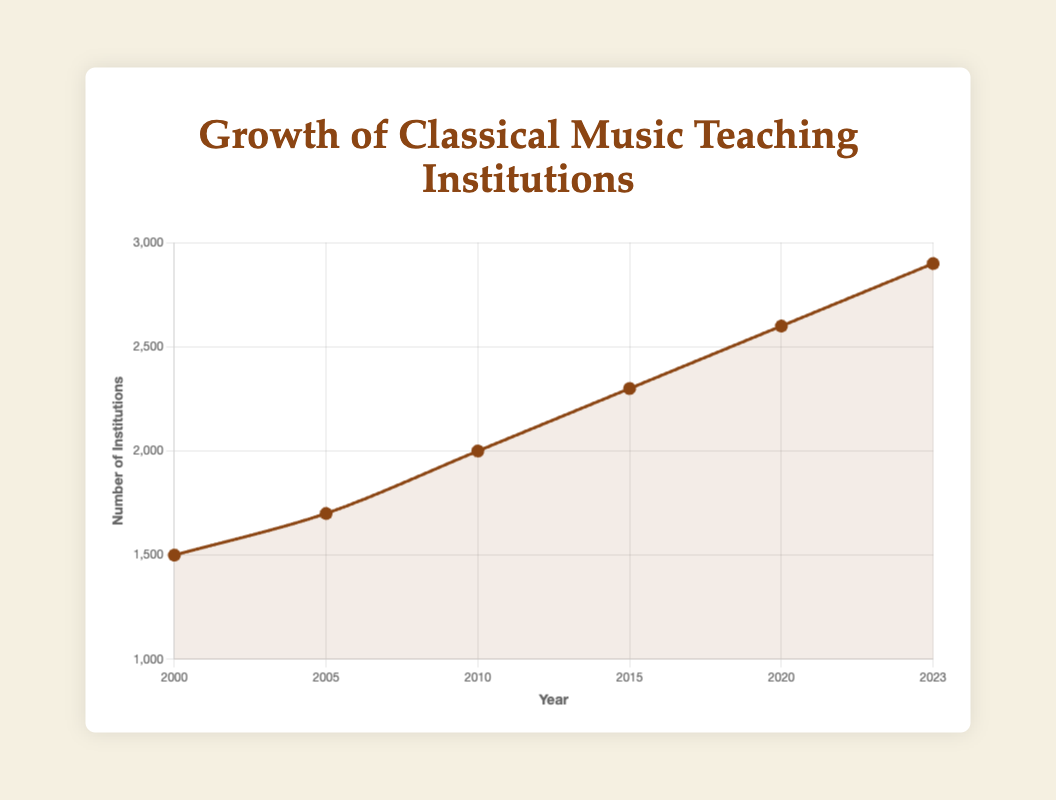How many institutions were there in 2015? By looking at the year 2015 on the x-axis and moving up to the corresponding point on the line, we can see the number of institutions.
Answer: 2300 What is the total increase in the number of institutions from 2000 to 2023? Calculate the difference between the number of institutions in 2023 and 2000: 2900 - 1500.
Answer: 1400 Which year had the largest increase in the number of institutions compared to the previous year? Compare the differences between consecutive data points: 
1700 - 1500 = 200 from 2000 to 2005,
2000 - 1700 = 300 from 2005 to 2010,
2300 - 2000 = 300 from 2010 to 2015,
2600 - 2300 = 300 from 2015 to 2020,
2900 - 2600 = 300 from 2020 to 2023. 
Since 2010 to 2023 has the largest equal increase, we consider it collectively.
Answer: 2010-2023 What is the average number of institutions in the years 2000, 2005, and 2010? Sum the number of institutions for these years and divide by 3: (1500 + 1700 + 2000) / 3.
Answer: 1733.33 How does the number of institutions in 2020 compare to 2010? Compare the values directly: 2600 in 2020 and 2000 in 2010. 2600 is greater than 2000.
Answer: 2020 is greater Which year marks the midpoint between the recorded data points and what is the number of institutions in that year? Midpoint of 2000 and 2023 is the year closest to halfway, i.e., 2011. The closest data point to 2011 is 2010 (with 2000 institutions).
Answer: 2010, 2000 institutions What is the average annual growth rate of institutions from 2000 to 2023? First, find the total increase: 2900 - 1500 = 1400. Then, divide by the number of years: 1400 / (2023 - 2000) = 1400 / 23.
Answer: 60.87 institutions/year What is the cumulative number of institutions added from 2000 to 2010? Add the increases between each interval: 
(1700 - 1500) + (2000 - 1700) 
= 200 + 300 = 500.
Answer: 500 Is the number of institutions doubling between 2000 and 2023? Compare 2000's value (1500) and 2023's value (2900). Doubling 1500 is 3000, but the 2023 value is 2900, slightly less.
Answer: No What is the trend line's color representing the number of institutions over time? Observing the plot, the line representing the institutions is a particular color.
Answer: Brown 